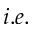<formula> <loc_0><loc_0><loc_500><loc_500>i . e .</formula> 